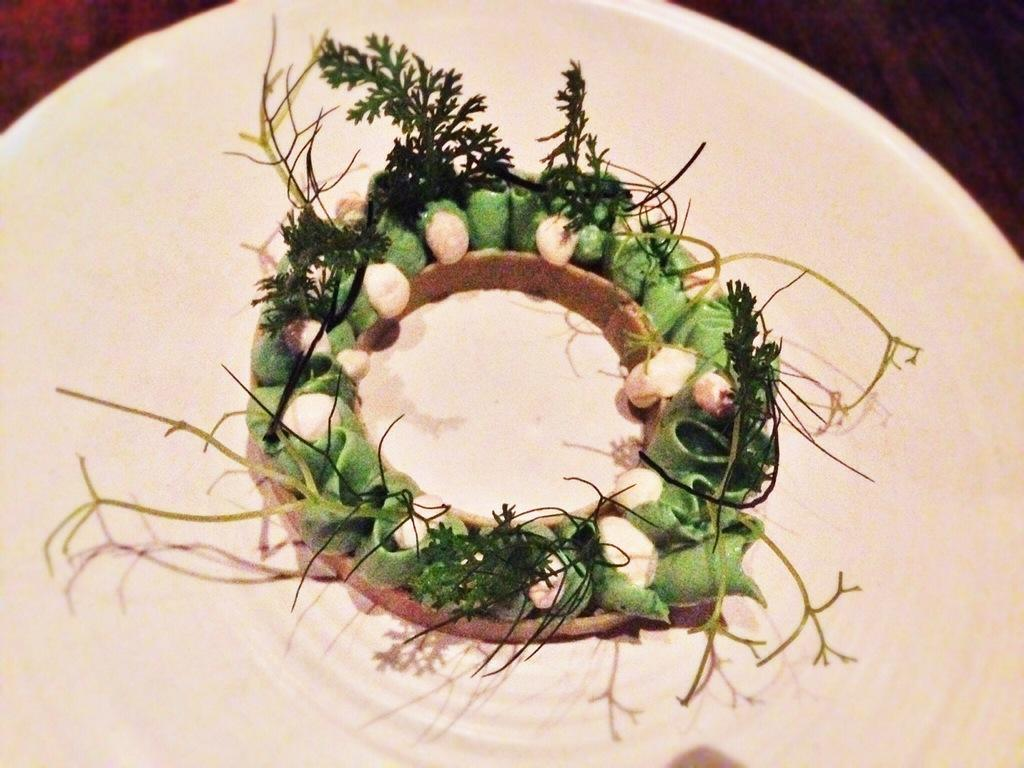What is on the plate that is visible in the image? The plate contains seeds and food items. How is the image taken, based on the perspective? The image appears to be taken from above the plate, as it looks like a table at the top of the image. Can you see any visible veins on the kitty in the image? There is no kitty present in the image, so we cannot see any visible veins on it. 